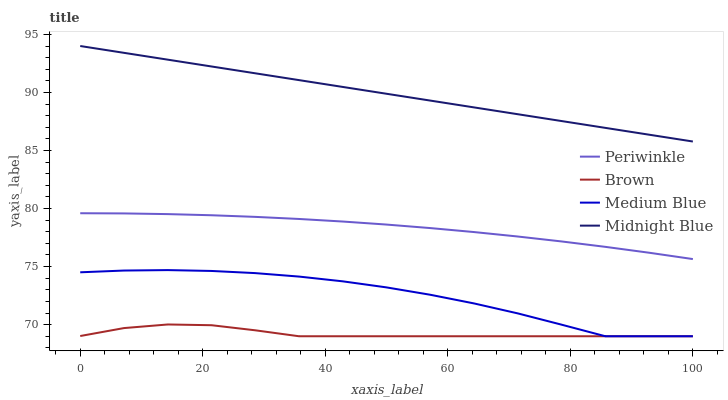Does Brown have the minimum area under the curve?
Answer yes or no. Yes. Does Midnight Blue have the maximum area under the curve?
Answer yes or no. Yes. Does Periwinkle have the minimum area under the curve?
Answer yes or no. No. Does Periwinkle have the maximum area under the curve?
Answer yes or no. No. Is Midnight Blue the smoothest?
Answer yes or no. Yes. Is Medium Blue the roughest?
Answer yes or no. Yes. Is Periwinkle the smoothest?
Answer yes or no. No. Is Periwinkle the roughest?
Answer yes or no. No. Does Brown have the lowest value?
Answer yes or no. Yes. Does Periwinkle have the lowest value?
Answer yes or no. No. Does Midnight Blue have the highest value?
Answer yes or no. Yes. Does Periwinkle have the highest value?
Answer yes or no. No. Is Periwinkle less than Midnight Blue?
Answer yes or no. Yes. Is Midnight Blue greater than Brown?
Answer yes or no. Yes. Does Brown intersect Medium Blue?
Answer yes or no. Yes. Is Brown less than Medium Blue?
Answer yes or no. No. Is Brown greater than Medium Blue?
Answer yes or no. No. Does Periwinkle intersect Midnight Blue?
Answer yes or no. No. 